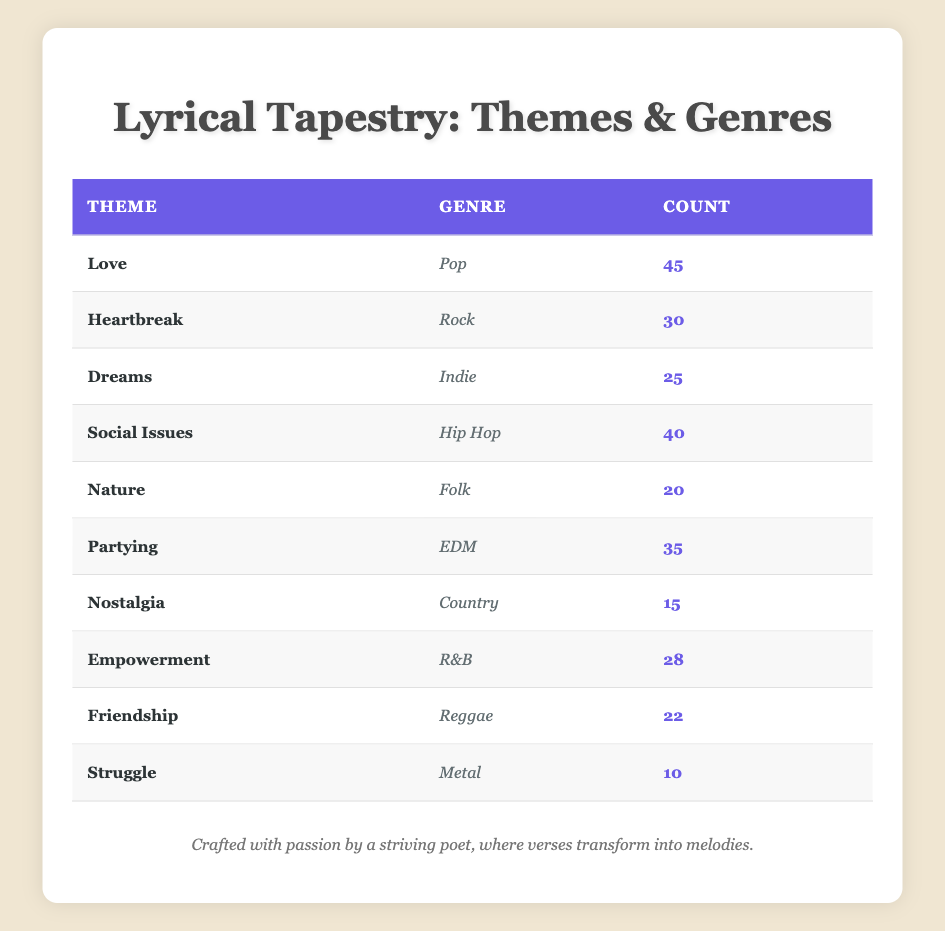What is the theme with the highest count in the table? By looking at the counts in the table, 'Love' has the highest count with 45.
Answer: Love How many themes are associated with genres that have a count greater than 30? From the table, the themes 'Love' (45), 'Social Issues' (40), 'Partying' (35), and 'Heartbreak' (30) have counts greater than 30. This totals to 4 themes.
Answer: 4 Is 'Nature' the least represented theme in terms of count? Yes, 'Nature' has a count of 20, which is less than 'Struggle' with a count of 10, making it not the least represented.
Answer: No What is the total count of songs for genres related to themes of empowerment and social issues? Adding the counts for 'Empowerment' (28) and 'Social Issues' (40) gives us a total of 68.
Answer: 68 Which genre has the least number of associated songs? The table shows 'Struggle' as being associated with 'Metal', which has the lowest count of 10.
Answer: Metal What is the average count of songs across all genres in the table? The total counts from the table are 45 + 30 + 25 + 40 + 20 + 35 + 15 + 28 + 22 + 10 =  300. Since there are 10 themes, the average is 300/10 = 30.
Answer: 30 How many themes are represented in Pop and EDM combined? The table lists 'Love' (Pop) and 'Partying' (EDM), resulting in a total of 2 unique themes represented by these genres.
Answer: 2 Does the count for 'Friendship' exceed that of 'Dreams'? Comparing the counts, 'Friendship' has a count of 22, while 'Dreams' has 25, thus 'Friendship' does not exceed 'Dreams'.
Answer: No Which themes belong to genres that received a count of at least 25? The themes that meet this criterion are 'Love' (Pop), 'Heartbreak' (Rock), 'Social Issues' (Hip Hop), 'Partying' (EDM), 'Empowerment' (R&B), and 'Dreams' (Indie), totaling 6 themes.
Answer: 6 